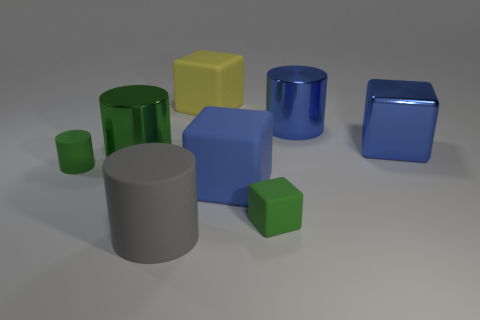Add 1 big shiny objects. How many objects exist? 9 Subtract all large cylinders. How many cylinders are left? 1 Add 2 yellow matte blocks. How many yellow matte blocks are left? 3 Add 3 small gray rubber cylinders. How many small gray rubber cylinders exist? 3 Subtract all gray cylinders. How many cylinders are left? 3 Subtract 2 green cylinders. How many objects are left? 6 Subtract 2 blocks. How many blocks are left? 2 Subtract all green cylinders. Subtract all yellow balls. How many cylinders are left? 2 Subtract all blue balls. How many gray cylinders are left? 1 Subtract all big blue shiny blocks. Subtract all big purple spheres. How many objects are left? 7 